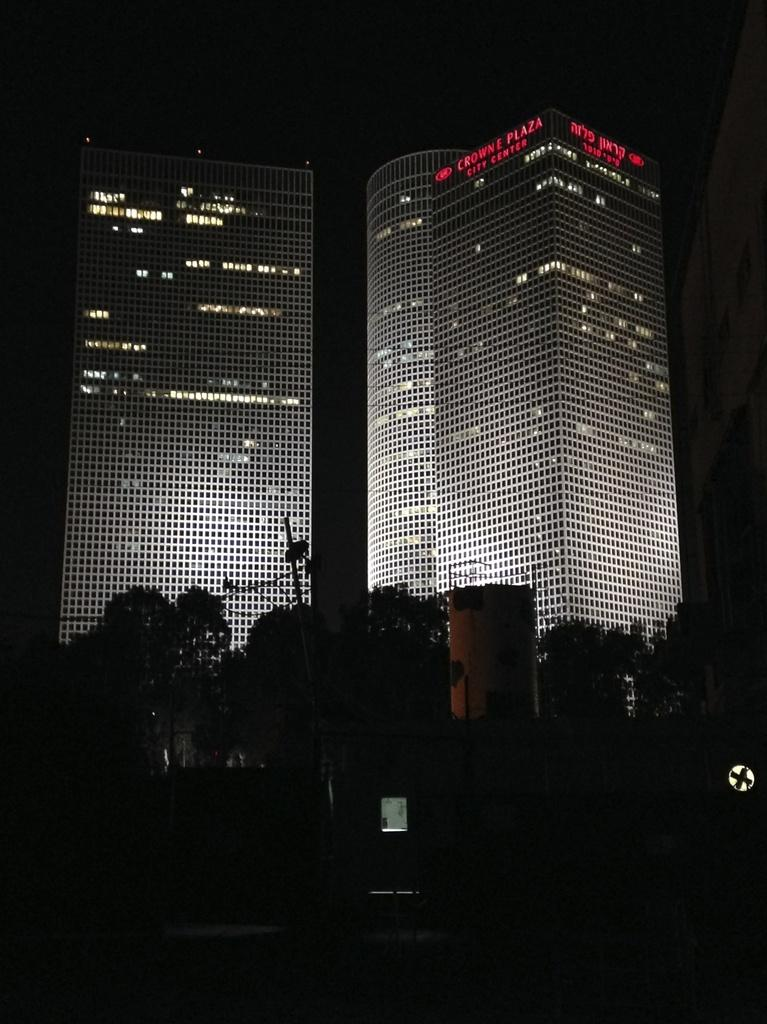What type of natural elements can be seen in the image? There are trees in the image. What type of man-made structures can be seen in the image? There are buildings visible in the background of the image. What type of wire is being used to express hate in the image? There is no wire or expression of hate present in the image. What type of skirt can be seen on the trees in the image? There are no skirts present in the image, as it features trees and buildings. 